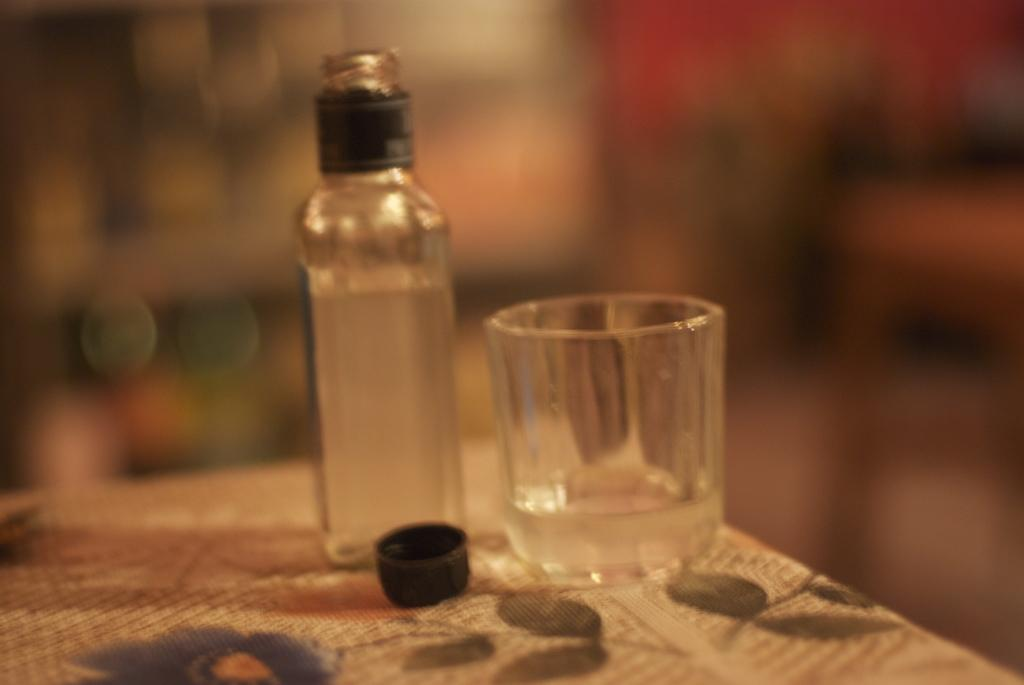What is the main piece of furniture in the image? There is a table in the image. What is covering the table? The table is covered with a cloth. What type of container is on the table? There is a glass on the table. What other items can be seen on the table? There is a cap and a bottle on the table. What is inside the bottle? There is a drink inside the bottle. What type of pollution is visible in the image? There is no visible pollution in the image; it only shows a table with a cloth, glass, cap, and bottle. 